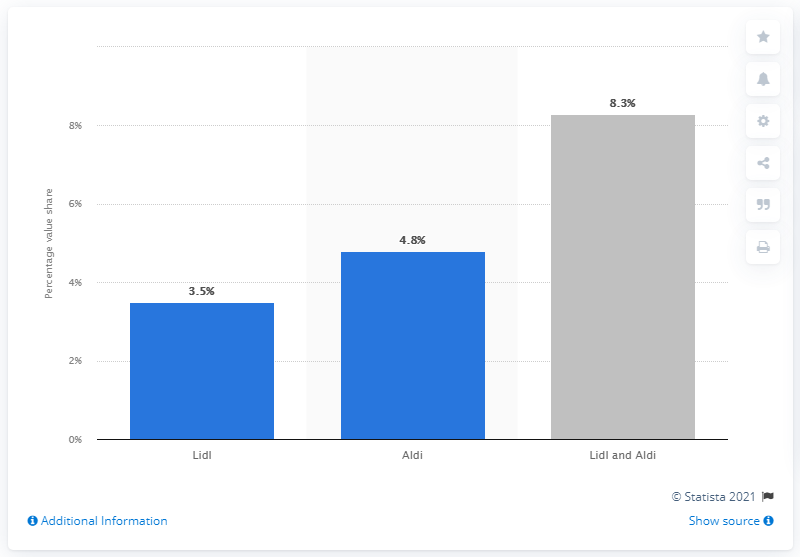Identify some key points in this picture. In 2019, Aldi and Lidl collectively held 8.3% of the British grocery market share. 